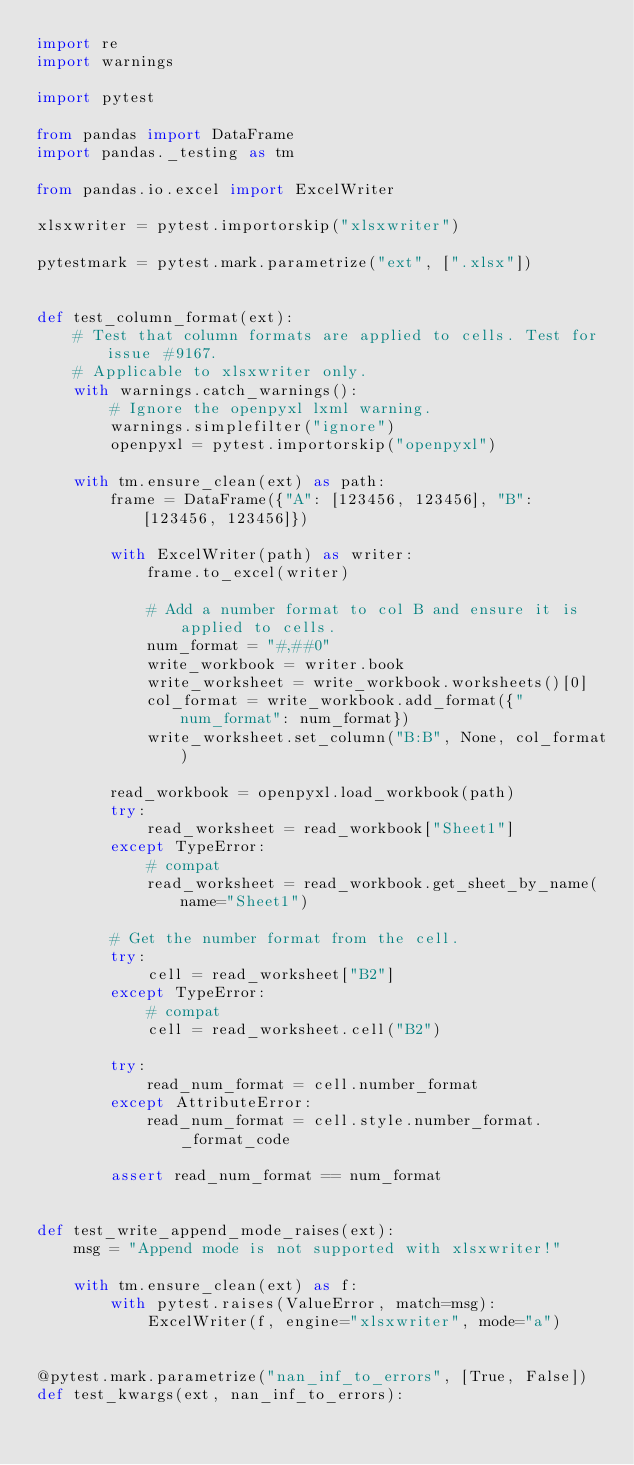Convert code to text. <code><loc_0><loc_0><loc_500><loc_500><_Python_>import re
import warnings

import pytest

from pandas import DataFrame
import pandas._testing as tm

from pandas.io.excel import ExcelWriter

xlsxwriter = pytest.importorskip("xlsxwriter")

pytestmark = pytest.mark.parametrize("ext", [".xlsx"])


def test_column_format(ext):
    # Test that column formats are applied to cells. Test for issue #9167.
    # Applicable to xlsxwriter only.
    with warnings.catch_warnings():
        # Ignore the openpyxl lxml warning.
        warnings.simplefilter("ignore")
        openpyxl = pytest.importorskip("openpyxl")

    with tm.ensure_clean(ext) as path:
        frame = DataFrame({"A": [123456, 123456], "B": [123456, 123456]})

        with ExcelWriter(path) as writer:
            frame.to_excel(writer)

            # Add a number format to col B and ensure it is applied to cells.
            num_format = "#,##0"
            write_workbook = writer.book
            write_worksheet = write_workbook.worksheets()[0]
            col_format = write_workbook.add_format({"num_format": num_format})
            write_worksheet.set_column("B:B", None, col_format)

        read_workbook = openpyxl.load_workbook(path)
        try:
            read_worksheet = read_workbook["Sheet1"]
        except TypeError:
            # compat
            read_worksheet = read_workbook.get_sheet_by_name(name="Sheet1")

        # Get the number format from the cell.
        try:
            cell = read_worksheet["B2"]
        except TypeError:
            # compat
            cell = read_worksheet.cell("B2")

        try:
            read_num_format = cell.number_format
        except AttributeError:
            read_num_format = cell.style.number_format._format_code

        assert read_num_format == num_format


def test_write_append_mode_raises(ext):
    msg = "Append mode is not supported with xlsxwriter!"

    with tm.ensure_clean(ext) as f:
        with pytest.raises(ValueError, match=msg):
            ExcelWriter(f, engine="xlsxwriter", mode="a")


@pytest.mark.parametrize("nan_inf_to_errors", [True, False])
def test_kwargs(ext, nan_inf_to_errors):</code> 